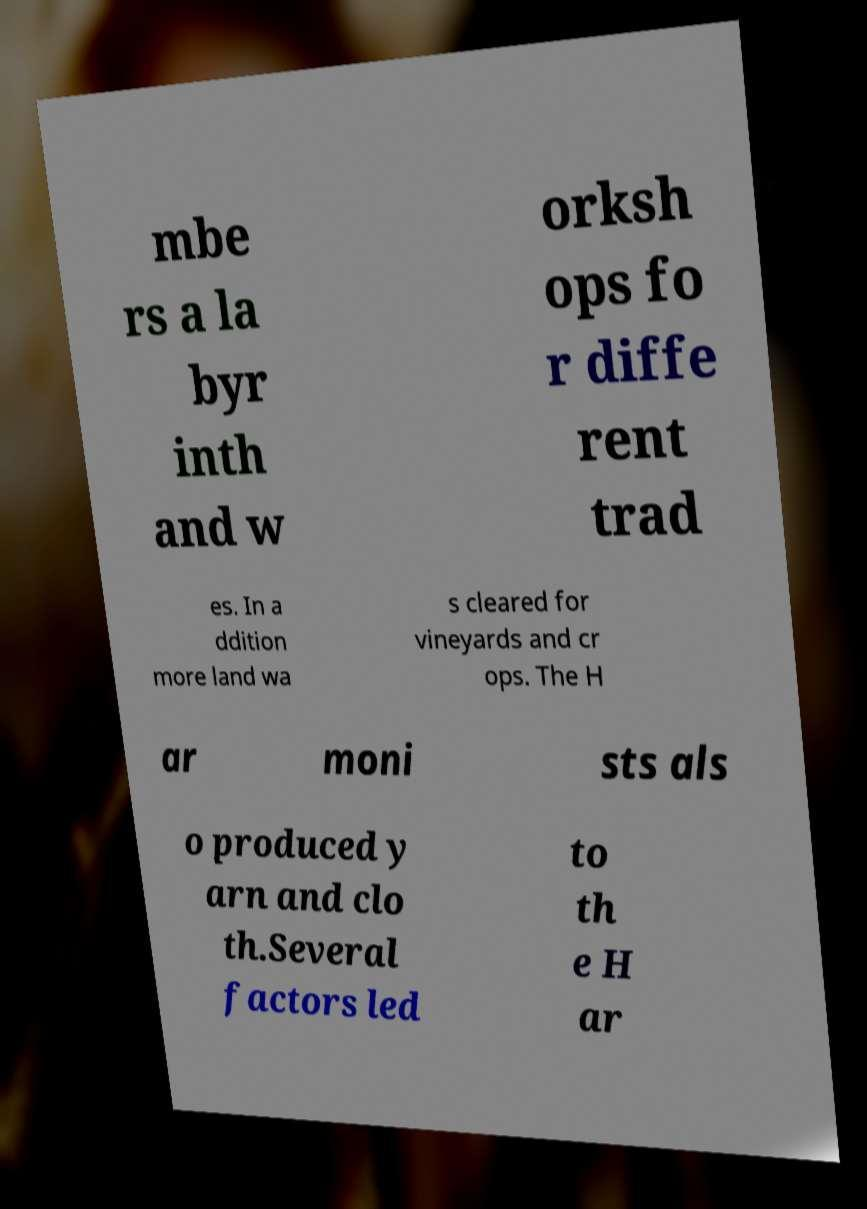Can you accurately transcribe the text from the provided image for me? mbe rs a la byr inth and w orksh ops fo r diffe rent trad es. In a ddition more land wa s cleared for vineyards and cr ops. The H ar moni sts als o produced y arn and clo th.Several factors led to th e H ar 